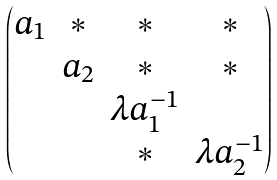<formula> <loc_0><loc_0><loc_500><loc_500>\begin{pmatrix} a _ { 1 } & \ast & \ast & \ast \\ & a _ { 2 } & \ast & \ast \\ & & \lambda a _ { 1 } ^ { - 1 } & \\ & & \ast & \lambda a _ { 2 } ^ { - 1 } \end{pmatrix}</formula> 